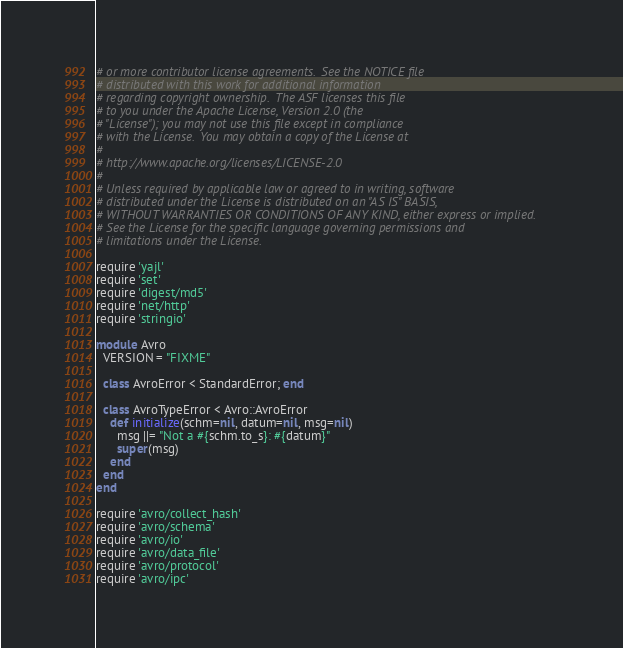Convert code to text. <code><loc_0><loc_0><loc_500><loc_500><_Ruby_># or more contributor license agreements.  See the NOTICE file
# distributed with this work for additional information
# regarding copyright ownership.  The ASF licenses this file
# to you under the Apache License, Version 2.0 (the
# "License"); you may not use this file except in compliance
# with the License.  You may obtain a copy of the License at
# 
# http://www.apache.org/licenses/LICENSE-2.0
# 
# Unless required by applicable law or agreed to in writing, software
# distributed under the License is distributed on an "AS IS" BASIS,
# WITHOUT WARRANTIES OR CONDITIONS OF ANY KIND, either express or implied.
# See the License for the specific language governing permissions and
# limitations under the License.

require 'yajl'
require 'set'
require 'digest/md5'
require 'net/http'
require 'stringio'

module Avro
  VERSION = "FIXME"

  class AvroError < StandardError; end

  class AvroTypeError < Avro::AvroError
    def initialize(schm=nil, datum=nil, msg=nil)
      msg ||= "Not a #{schm.to_s}: #{datum}"
      super(msg)
    end
  end
end

require 'avro/collect_hash'
require 'avro/schema'
require 'avro/io'
require 'avro/data_file'
require 'avro/protocol'
require 'avro/ipc'
</code> 